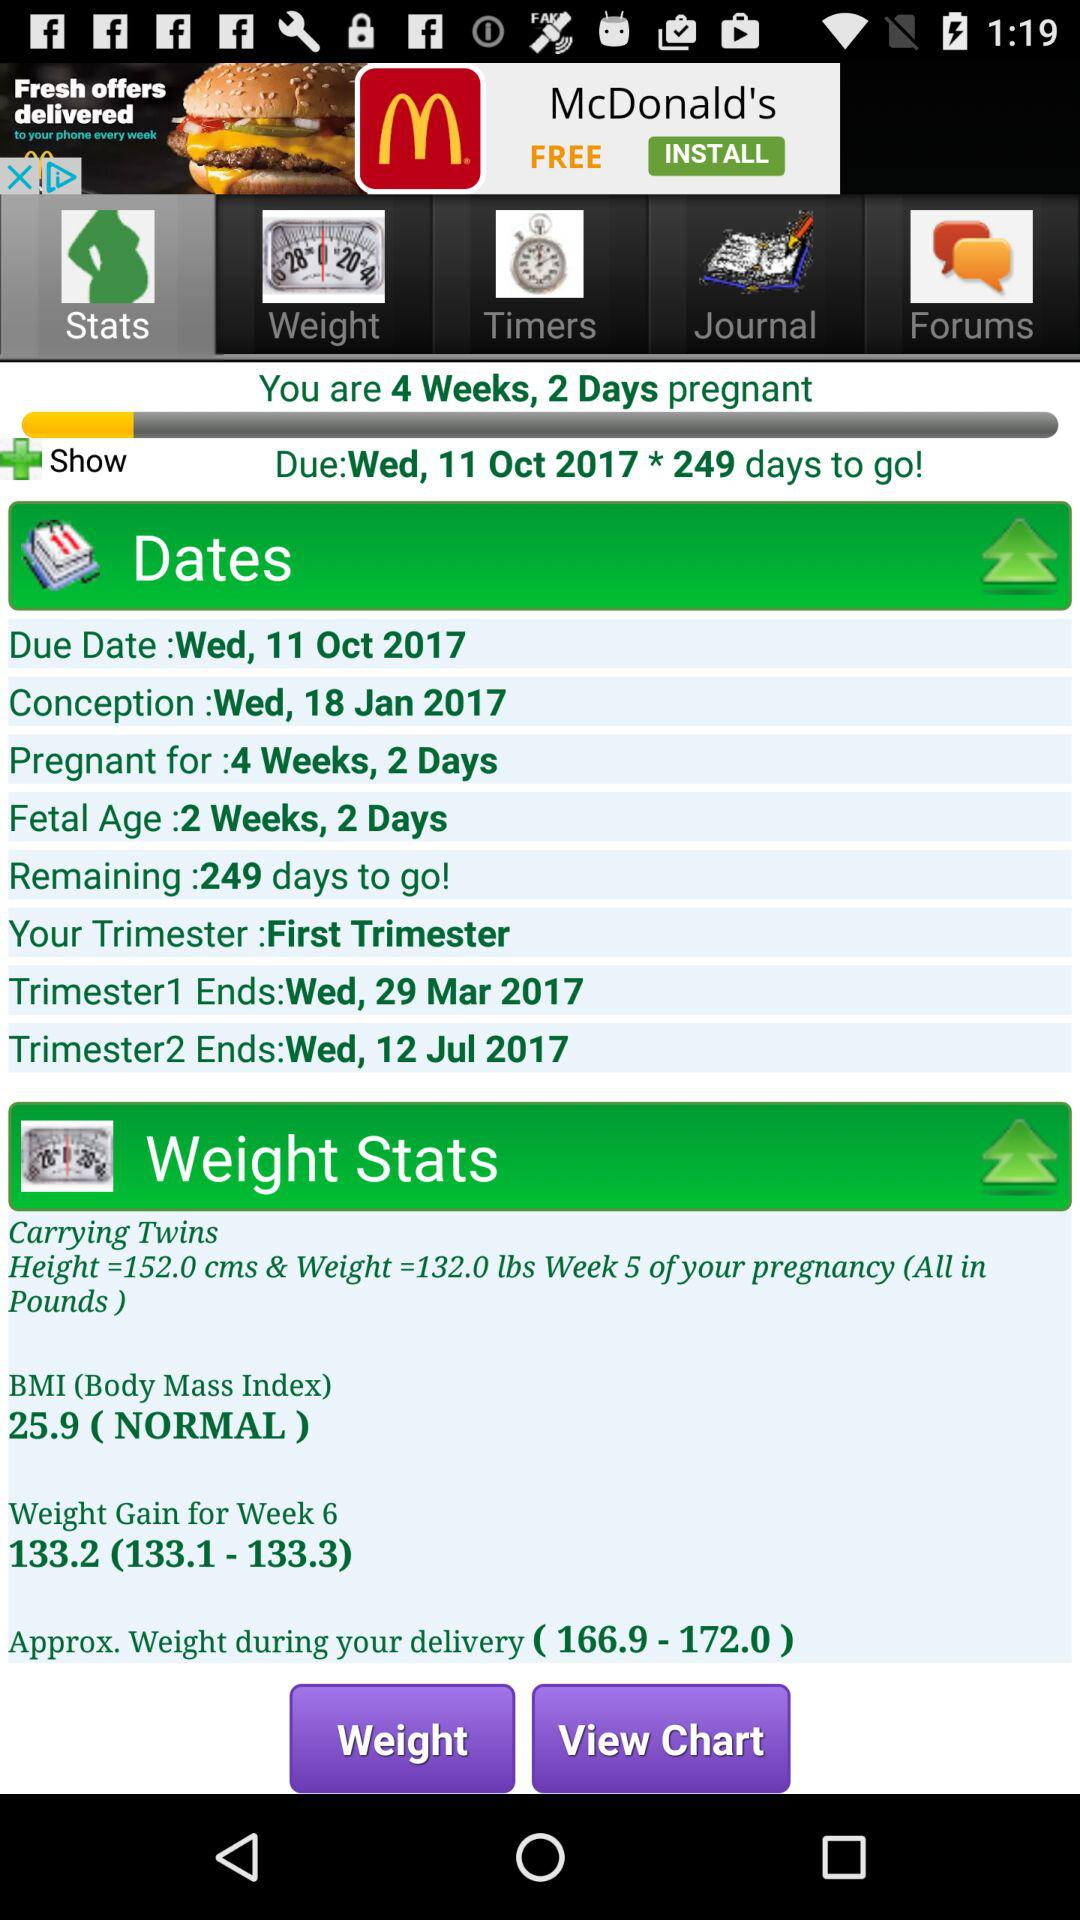What is the due date? The due date is Wednesday, October 11, 2017. 